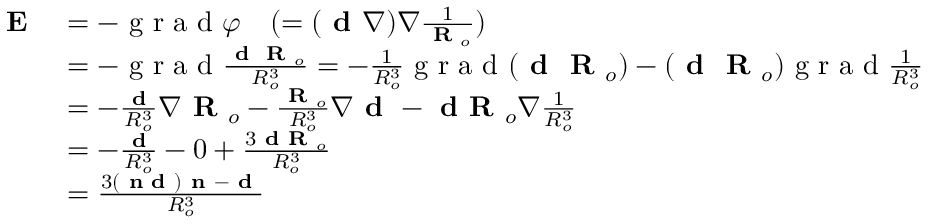Convert formula to latex. <formula><loc_0><loc_0><loc_500><loc_500>\begin{array} { r l } { E } & { = - g r a d \varphi \quad ( = ( d \nabla ) \nabla \frac { 1 } { R _ { o } } ) } \\ & { = - g r a d \frac { d R _ { o } } { R _ { o } ^ { 3 } } = - \frac { 1 } { R _ { o } ^ { 3 } } g r a d ( d R _ { o } ) - ( d R _ { o } ) g r a d \frac { 1 } { R _ { o } ^ { 3 } } } \\ & { = - \frac { d } { R _ { o } ^ { 3 } } \nabla R _ { o } - \frac { R _ { o } } { R _ { o } ^ { 3 } } \nabla d - d R _ { o } \nabla \frac { 1 } { R _ { o } ^ { 3 } } } \\ & { = - \frac { d } { R _ { o } ^ { 3 } } - 0 + \frac { 3 d R _ { o } } { R _ { o } ^ { 3 } } } \\ & { = \frac { 3 ( n d ) n - d } { R _ { o } ^ { 3 } } } \end{array}</formula> 